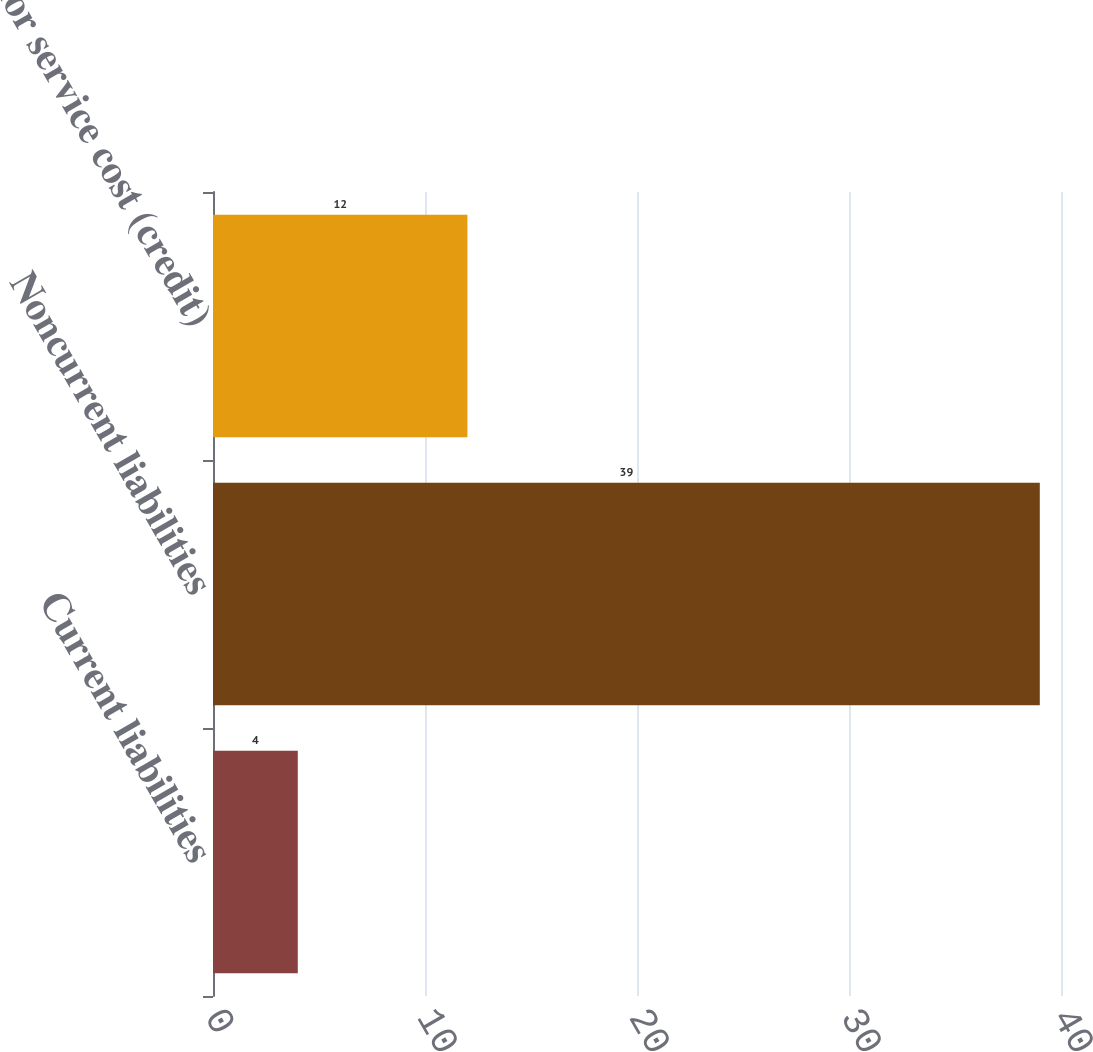<chart> <loc_0><loc_0><loc_500><loc_500><bar_chart><fcel>Current liabilities<fcel>Noncurrent liabilities<fcel>Prior service cost (credit)<nl><fcel>4<fcel>39<fcel>12<nl></chart> 